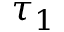<formula> <loc_0><loc_0><loc_500><loc_500>\tau _ { 1 }</formula> 